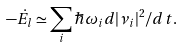<formula> <loc_0><loc_0><loc_500><loc_500>- \dot { E } _ { l } \simeq \sum _ { i } \hbar { \omega } _ { i } d | \nu _ { i } | ^ { 2 } / d t .</formula> 